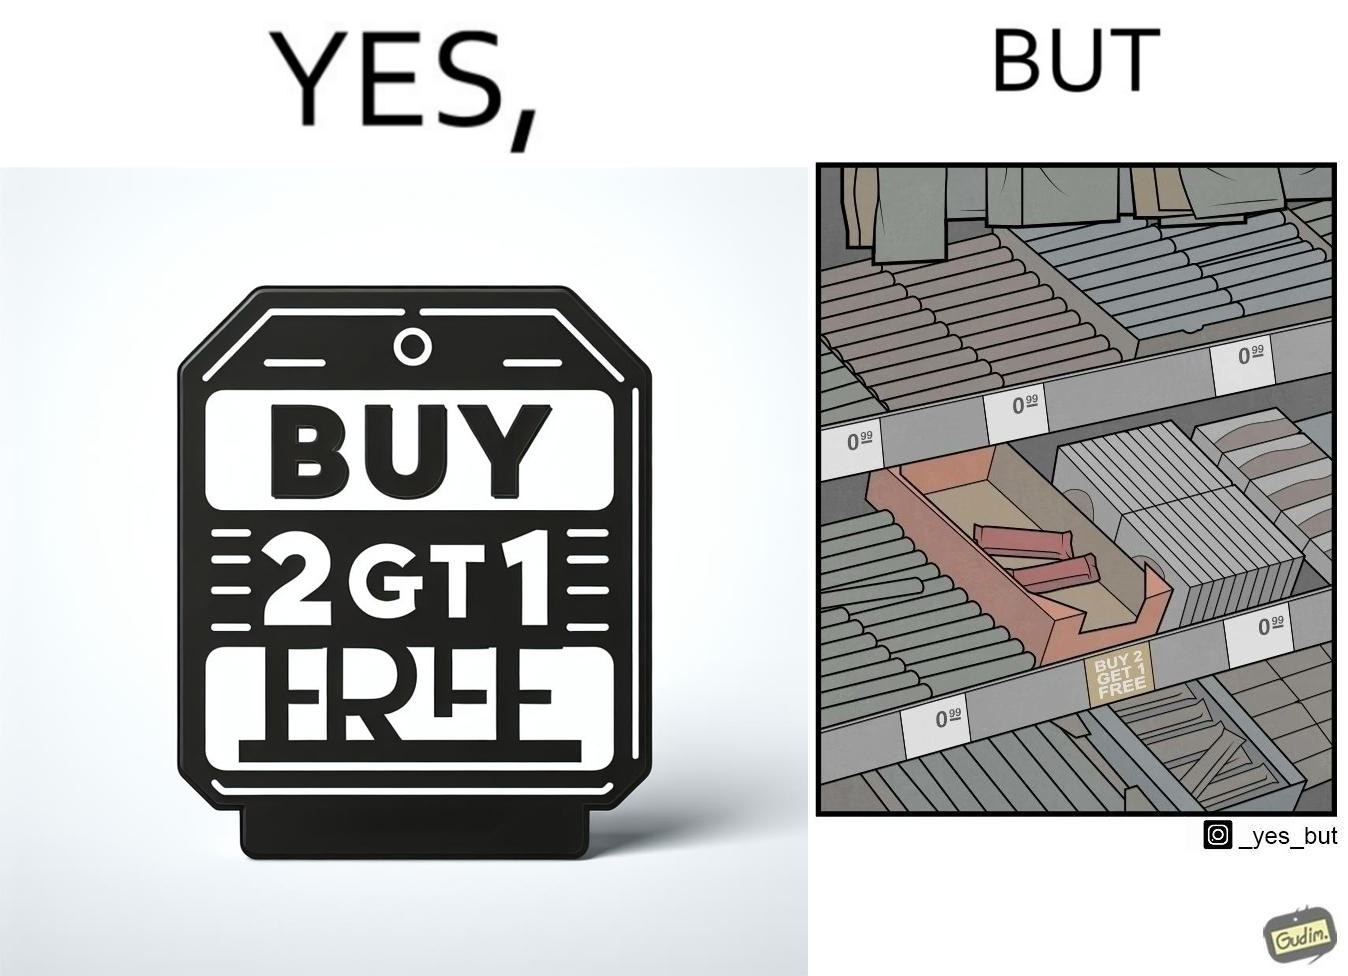Is this image satirical or non-satirical? Yes, this image is satirical. 